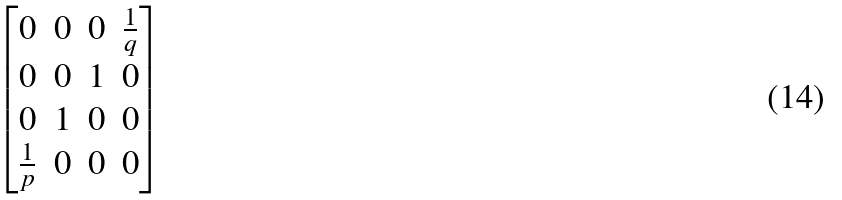<formula> <loc_0><loc_0><loc_500><loc_500>\begin{bmatrix} 0 & 0 & 0 & \frac { 1 } { q } \\ 0 & 0 & 1 & 0 \\ 0 & 1 & 0 & 0 \\ \frac { 1 } { p } & 0 & 0 & 0 \end{bmatrix}</formula> 